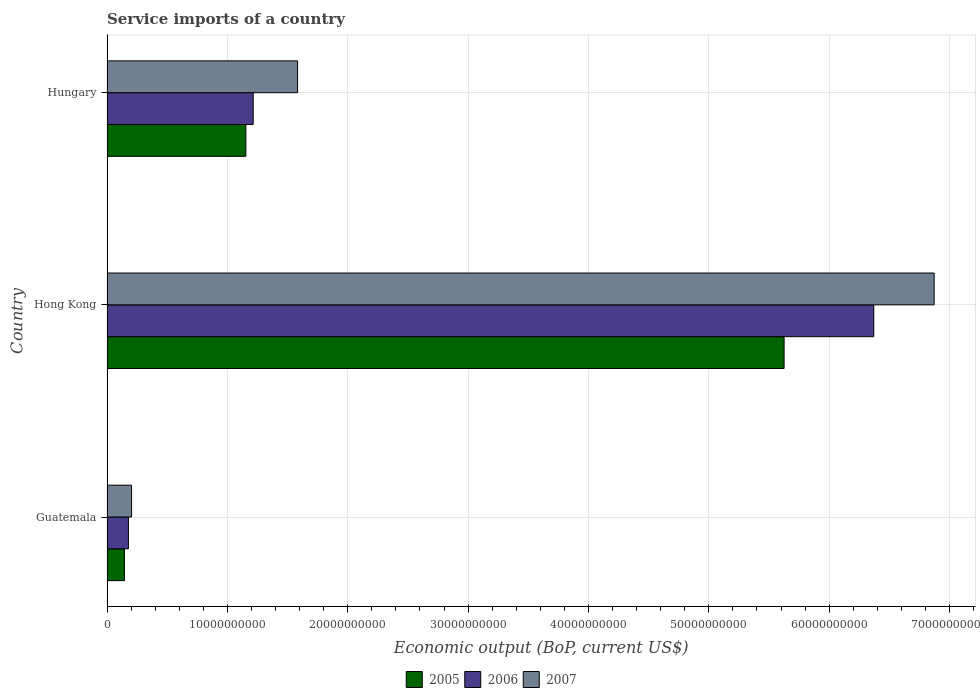How many groups of bars are there?
Keep it short and to the point. 3. Are the number of bars per tick equal to the number of legend labels?
Your answer should be compact. Yes. Are the number of bars on each tick of the Y-axis equal?
Provide a short and direct response. Yes. How many bars are there on the 3rd tick from the top?
Your answer should be compact. 3. How many bars are there on the 1st tick from the bottom?
Provide a short and direct response. 3. What is the label of the 3rd group of bars from the top?
Offer a very short reply. Guatemala. What is the service imports in 2005 in Hungary?
Make the answer very short. 1.15e+1. Across all countries, what is the maximum service imports in 2006?
Offer a terse response. 6.37e+1. Across all countries, what is the minimum service imports in 2007?
Your response must be concise. 2.04e+09. In which country was the service imports in 2006 maximum?
Your answer should be compact. Hong Kong. In which country was the service imports in 2006 minimum?
Your answer should be very brief. Guatemala. What is the total service imports in 2005 in the graph?
Provide a short and direct response. 6.92e+1. What is the difference between the service imports in 2005 in Guatemala and that in Hungary?
Offer a very short reply. -1.01e+1. What is the difference between the service imports in 2007 in Hong Kong and the service imports in 2005 in Hungary?
Offer a very short reply. 5.72e+1. What is the average service imports in 2005 per country?
Provide a succinct answer. 2.31e+1. What is the difference between the service imports in 2007 and service imports in 2005 in Guatemala?
Your response must be concise. 5.92e+08. In how many countries, is the service imports in 2005 greater than 8000000000 US$?
Offer a very short reply. 2. What is the ratio of the service imports in 2005 in Guatemala to that in Hungary?
Offer a terse response. 0.13. Is the service imports in 2005 in Guatemala less than that in Hungary?
Offer a terse response. Yes. What is the difference between the highest and the second highest service imports in 2005?
Your response must be concise. 4.47e+1. What is the difference between the highest and the lowest service imports in 2005?
Offer a terse response. 5.48e+1. In how many countries, is the service imports in 2007 greater than the average service imports in 2007 taken over all countries?
Your response must be concise. 1. What does the 2nd bar from the top in Hong Kong represents?
Make the answer very short. 2006. What does the 1st bar from the bottom in Guatemala represents?
Your answer should be very brief. 2005. Are all the bars in the graph horizontal?
Make the answer very short. Yes. Are the values on the major ticks of X-axis written in scientific E-notation?
Ensure brevity in your answer.  No. Does the graph contain grids?
Provide a succinct answer. Yes. Where does the legend appear in the graph?
Make the answer very short. Bottom center. How are the legend labels stacked?
Give a very brief answer. Horizontal. What is the title of the graph?
Your response must be concise. Service imports of a country. Does "1983" appear as one of the legend labels in the graph?
Your response must be concise. No. What is the label or title of the X-axis?
Give a very brief answer. Economic output (BoP, current US$). What is the Economic output (BoP, current US$) in 2005 in Guatemala?
Your answer should be compact. 1.45e+09. What is the Economic output (BoP, current US$) in 2006 in Guatemala?
Provide a short and direct response. 1.78e+09. What is the Economic output (BoP, current US$) of 2007 in Guatemala?
Your response must be concise. 2.04e+09. What is the Economic output (BoP, current US$) of 2005 in Hong Kong?
Provide a short and direct response. 5.63e+1. What is the Economic output (BoP, current US$) in 2006 in Hong Kong?
Offer a terse response. 6.37e+1. What is the Economic output (BoP, current US$) in 2007 in Hong Kong?
Give a very brief answer. 6.87e+1. What is the Economic output (BoP, current US$) in 2005 in Hungary?
Ensure brevity in your answer.  1.15e+1. What is the Economic output (BoP, current US$) in 2006 in Hungary?
Keep it short and to the point. 1.21e+1. What is the Economic output (BoP, current US$) in 2007 in Hungary?
Provide a succinct answer. 1.58e+1. Across all countries, what is the maximum Economic output (BoP, current US$) of 2005?
Offer a very short reply. 5.63e+1. Across all countries, what is the maximum Economic output (BoP, current US$) in 2006?
Your response must be concise. 6.37e+1. Across all countries, what is the maximum Economic output (BoP, current US$) of 2007?
Ensure brevity in your answer.  6.87e+1. Across all countries, what is the minimum Economic output (BoP, current US$) of 2005?
Make the answer very short. 1.45e+09. Across all countries, what is the minimum Economic output (BoP, current US$) of 2006?
Give a very brief answer. 1.78e+09. Across all countries, what is the minimum Economic output (BoP, current US$) of 2007?
Give a very brief answer. 2.04e+09. What is the total Economic output (BoP, current US$) of 2005 in the graph?
Provide a short and direct response. 6.92e+1. What is the total Economic output (BoP, current US$) in 2006 in the graph?
Your answer should be very brief. 7.76e+1. What is the total Economic output (BoP, current US$) in 2007 in the graph?
Give a very brief answer. 8.66e+1. What is the difference between the Economic output (BoP, current US$) of 2005 in Guatemala and that in Hong Kong?
Make the answer very short. -5.48e+1. What is the difference between the Economic output (BoP, current US$) in 2006 in Guatemala and that in Hong Kong?
Provide a short and direct response. -6.19e+1. What is the difference between the Economic output (BoP, current US$) of 2007 in Guatemala and that in Hong Kong?
Keep it short and to the point. -6.67e+1. What is the difference between the Economic output (BoP, current US$) in 2005 in Guatemala and that in Hungary?
Offer a very short reply. -1.01e+1. What is the difference between the Economic output (BoP, current US$) of 2006 in Guatemala and that in Hungary?
Provide a short and direct response. -1.04e+1. What is the difference between the Economic output (BoP, current US$) of 2007 in Guatemala and that in Hungary?
Offer a terse response. -1.38e+1. What is the difference between the Economic output (BoP, current US$) of 2005 in Hong Kong and that in Hungary?
Your response must be concise. 4.47e+1. What is the difference between the Economic output (BoP, current US$) in 2006 in Hong Kong and that in Hungary?
Your response must be concise. 5.16e+1. What is the difference between the Economic output (BoP, current US$) of 2007 in Hong Kong and that in Hungary?
Ensure brevity in your answer.  5.29e+1. What is the difference between the Economic output (BoP, current US$) in 2005 in Guatemala and the Economic output (BoP, current US$) in 2006 in Hong Kong?
Offer a terse response. -6.23e+1. What is the difference between the Economic output (BoP, current US$) of 2005 in Guatemala and the Economic output (BoP, current US$) of 2007 in Hong Kong?
Keep it short and to the point. -6.73e+1. What is the difference between the Economic output (BoP, current US$) of 2006 in Guatemala and the Economic output (BoP, current US$) of 2007 in Hong Kong?
Your answer should be very brief. -6.69e+1. What is the difference between the Economic output (BoP, current US$) of 2005 in Guatemala and the Economic output (BoP, current US$) of 2006 in Hungary?
Provide a succinct answer. -1.07e+1. What is the difference between the Economic output (BoP, current US$) in 2005 in Guatemala and the Economic output (BoP, current US$) in 2007 in Hungary?
Offer a very short reply. -1.44e+1. What is the difference between the Economic output (BoP, current US$) in 2006 in Guatemala and the Economic output (BoP, current US$) in 2007 in Hungary?
Give a very brief answer. -1.41e+1. What is the difference between the Economic output (BoP, current US$) of 2005 in Hong Kong and the Economic output (BoP, current US$) of 2006 in Hungary?
Offer a very short reply. 4.41e+1. What is the difference between the Economic output (BoP, current US$) of 2005 in Hong Kong and the Economic output (BoP, current US$) of 2007 in Hungary?
Offer a terse response. 4.04e+1. What is the difference between the Economic output (BoP, current US$) of 2006 in Hong Kong and the Economic output (BoP, current US$) of 2007 in Hungary?
Make the answer very short. 4.79e+1. What is the average Economic output (BoP, current US$) of 2005 per country?
Ensure brevity in your answer.  2.31e+1. What is the average Economic output (BoP, current US$) of 2006 per country?
Your response must be concise. 2.59e+1. What is the average Economic output (BoP, current US$) of 2007 per country?
Your response must be concise. 2.89e+1. What is the difference between the Economic output (BoP, current US$) in 2005 and Economic output (BoP, current US$) in 2006 in Guatemala?
Ensure brevity in your answer.  -3.29e+08. What is the difference between the Economic output (BoP, current US$) of 2005 and Economic output (BoP, current US$) of 2007 in Guatemala?
Offer a terse response. -5.92e+08. What is the difference between the Economic output (BoP, current US$) in 2006 and Economic output (BoP, current US$) in 2007 in Guatemala?
Your response must be concise. -2.63e+08. What is the difference between the Economic output (BoP, current US$) of 2005 and Economic output (BoP, current US$) of 2006 in Hong Kong?
Your answer should be compact. -7.45e+09. What is the difference between the Economic output (BoP, current US$) of 2005 and Economic output (BoP, current US$) of 2007 in Hong Kong?
Your answer should be very brief. -1.25e+1. What is the difference between the Economic output (BoP, current US$) in 2006 and Economic output (BoP, current US$) in 2007 in Hong Kong?
Provide a succinct answer. -5.01e+09. What is the difference between the Economic output (BoP, current US$) of 2005 and Economic output (BoP, current US$) of 2006 in Hungary?
Your answer should be compact. -6.10e+08. What is the difference between the Economic output (BoP, current US$) in 2005 and Economic output (BoP, current US$) in 2007 in Hungary?
Provide a succinct answer. -4.30e+09. What is the difference between the Economic output (BoP, current US$) in 2006 and Economic output (BoP, current US$) in 2007 in Hungary?
Make the answer very short. -3.69e+09. What is the ratio of the Economic output (BoP, current US$) in 2005 in Guatemala to that in Hong Kong?
Make the answer very short. 0.03. What is the ratio of the Economic output (BoP, current US$) in 2006 in Guatemala to that in Hong Kong?
Your response must be concise. 0.03. What is the ratio of the Economic output (BoP, current US$) of 2007 in Guatemala to that in Hong Kong?
Offer a very short reply. 0.03. What is the ratio of the Economic output (BoP, current US$) in 2005 in Guatemala to that in Hungary?
Provide a succinct answer. 0.13. What is the ratio of the Economic output (BoP, current US$) of 2006 in Guatemala to that in Hungary?
Give a very brief answer. 0.15. What is the ratio of the Economic output (BoP, current US$) of 2007 in Guatemala to that in Hungary?
Offer a very short reply. 0.13. What is the ratio of the Economic output (BoP, current US$) in 2005 in Hong Kong to that in Hungary?
Provide a short and direct response. 4.88. What is the ratio of the Economic output (BoP, current US$) in 2006 in Hong Kong to that in Hungary?
Offer a very short reply. 5.25. What is the ratio of the Economic output (BoP, current US$) of 2007 in Hong Kong to that in Hungary?
Provide a succinct answer. 4.34. What is the difference between the highest and the second highest Economic output (BoP, current US$) of 2005?
Give a very brief answer. 4.47e+1. What is the difference between the highest and the second highest Economic output (BoP, current US$) in 2006?
Offer a terse response. 5.16e+1. What is the difference between the highest and the second highest Economic output (BoP, current US$) in 2007?
Make the answer very short. 5.29e+1. What is the difference between the highest and the lowest Economic output (BoP, current US$) in 2005?
Your answer should be compact. 5.48e+1. What is the difference between the highest and the lowest Economic output (BoP, current US$) of 2006?
Your response must be concise. 6.19e+1. What is the difference between the highest and the lowest Economic output (BoP, current US$) of 2007?
Provide a short and direct response. 6.67e+1. 